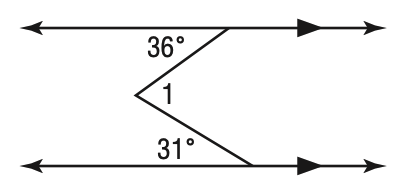Answer the mathemtical geometry problem and directly provide the correct option letter.
Question: Find m \angle 1.
Choices: A: 31 B: 36 C: 67 D: 77 C 